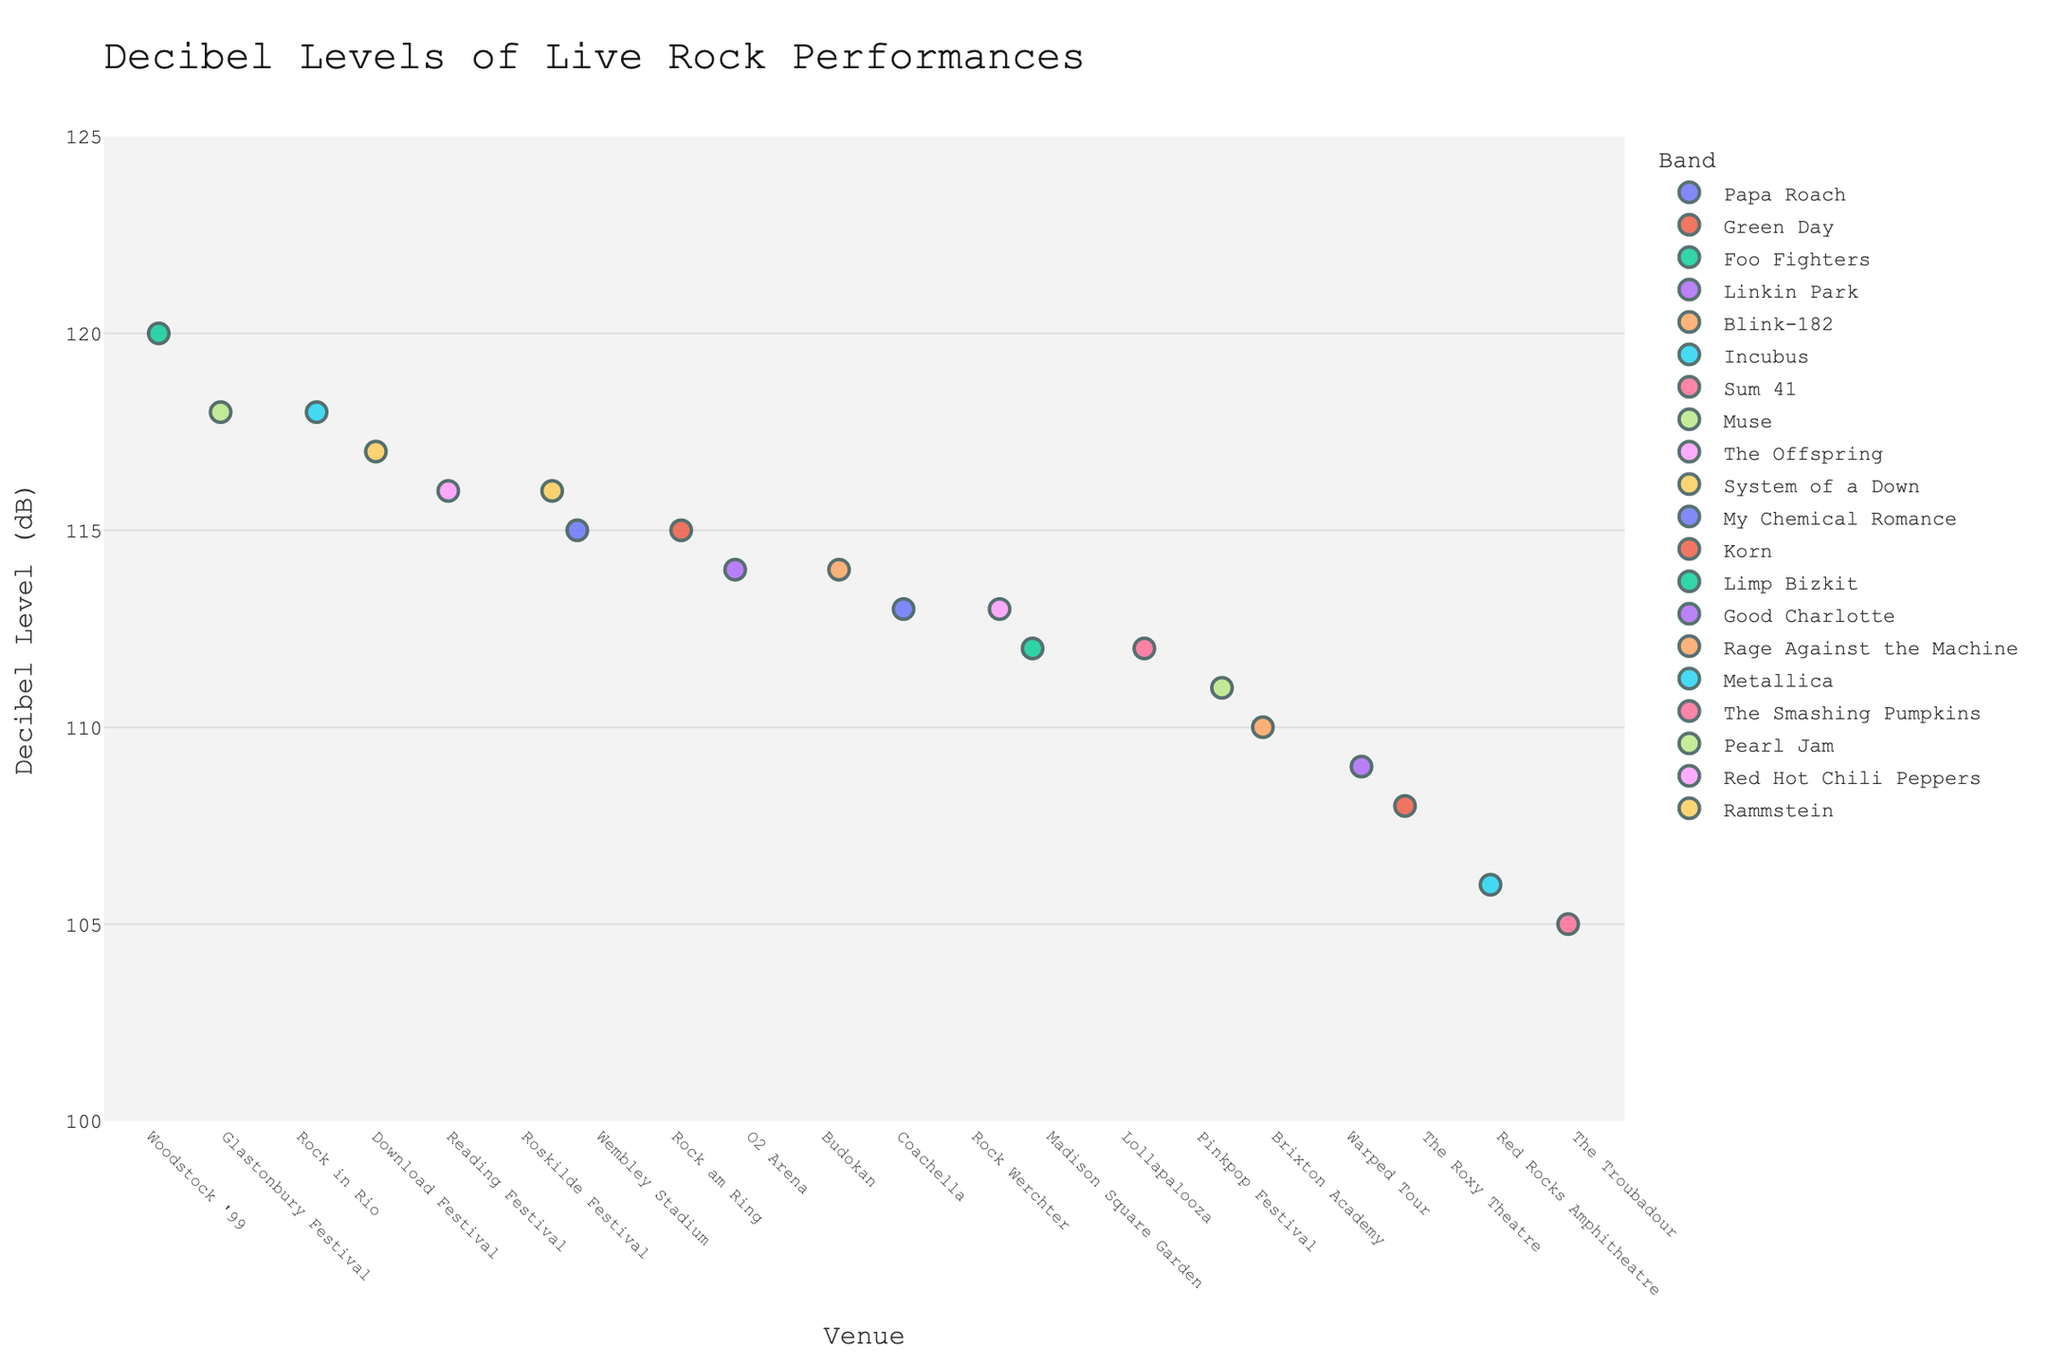What is the title of the strip plot? The title is located at the top of the plot and is usually surrounded by noticeable font and/or color differences from other elements in the plot.
Answer: Decibel Levels of Live Rock Performances Which venue has the highest recorded decibel level, and for which band? Look for the dot at the highest point on the y-axis, then identify the corresponding x-axis label and color-coded band.
Answer: Woodstock '99, Limp Bizkit How many bands have performed with a decibel level above 115 dB? Count the number of dots that are positioned above the 115 dB mark on the y-axis.
Answer: 7 Which band performed at Wembley Stadium, and what was the decibel level? Locate the x-axis label for "Wembley Stadium" and find the band information from the corresponding dot's hover info.
Answer: Papa Roach, 115 dB What is the range of decibel levels at the O2 Arena? Identify the dots above the x-axis label "O2 Arena" and note the lowest and highest y-axis values among them.
Answer: 114 dB Which performance has the lowest recorded decibel level, and at which venue did it occur? Find the dot at the lowest position on the y-axis, then identify the corresponding x-axis label and color-coded band.
Answer: The Troubadour, Sum 41 Between Glastonbury Festival and Rock in Rio, which venue has a higher maximum decibel level? Compare the highest points of the dots above the labels "Glastonbury Festival" and "Rock in Rio".
Answer: Both have 118 dB What is the median decibel level of performances at Brixton Academy and Madison Square Garden combined? List the decibel levels of both venues, arrange them in ascending order, and find the middle value.
Answer: 111 dB Which band has performed at the Pinkpop Festival, and what was the decibel level? Locate the x-axis label "Pinkpop Festival" and identify the color-coded band and y-axis value.
Answer: Pearl Jam, 111 dB How many venues have at least one performance with a decibel level above 110 dB? Count the number of unique x-axis labels with at least one dot above the 110 dB mark on the y-axis.
Answer: 17 